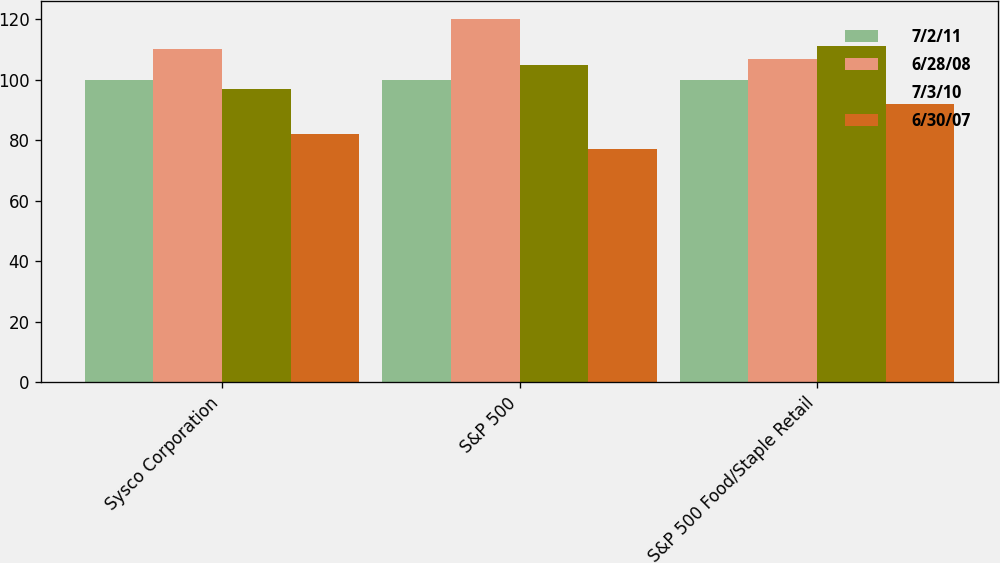<chart> <loc_0><loc_0><loc_500><loc_500><stacked_bar_chart><ecel><fcel>Sysco Corporation<fcel>S&P 500<fcel>S&P 500 Food/Staple Retail<nl><fcel>7/2/11<fcel>100<fcel>100<fcel>100<nl><fcel>6/28/08<fcel>110<fcel>120<fcel>107<nl><fcel>7/3/10<fcel>97<fcel>105<fcel>111<nl><fcel>6/30/07<fcel>82<fcel>77<fcel>92<nl></chart> 